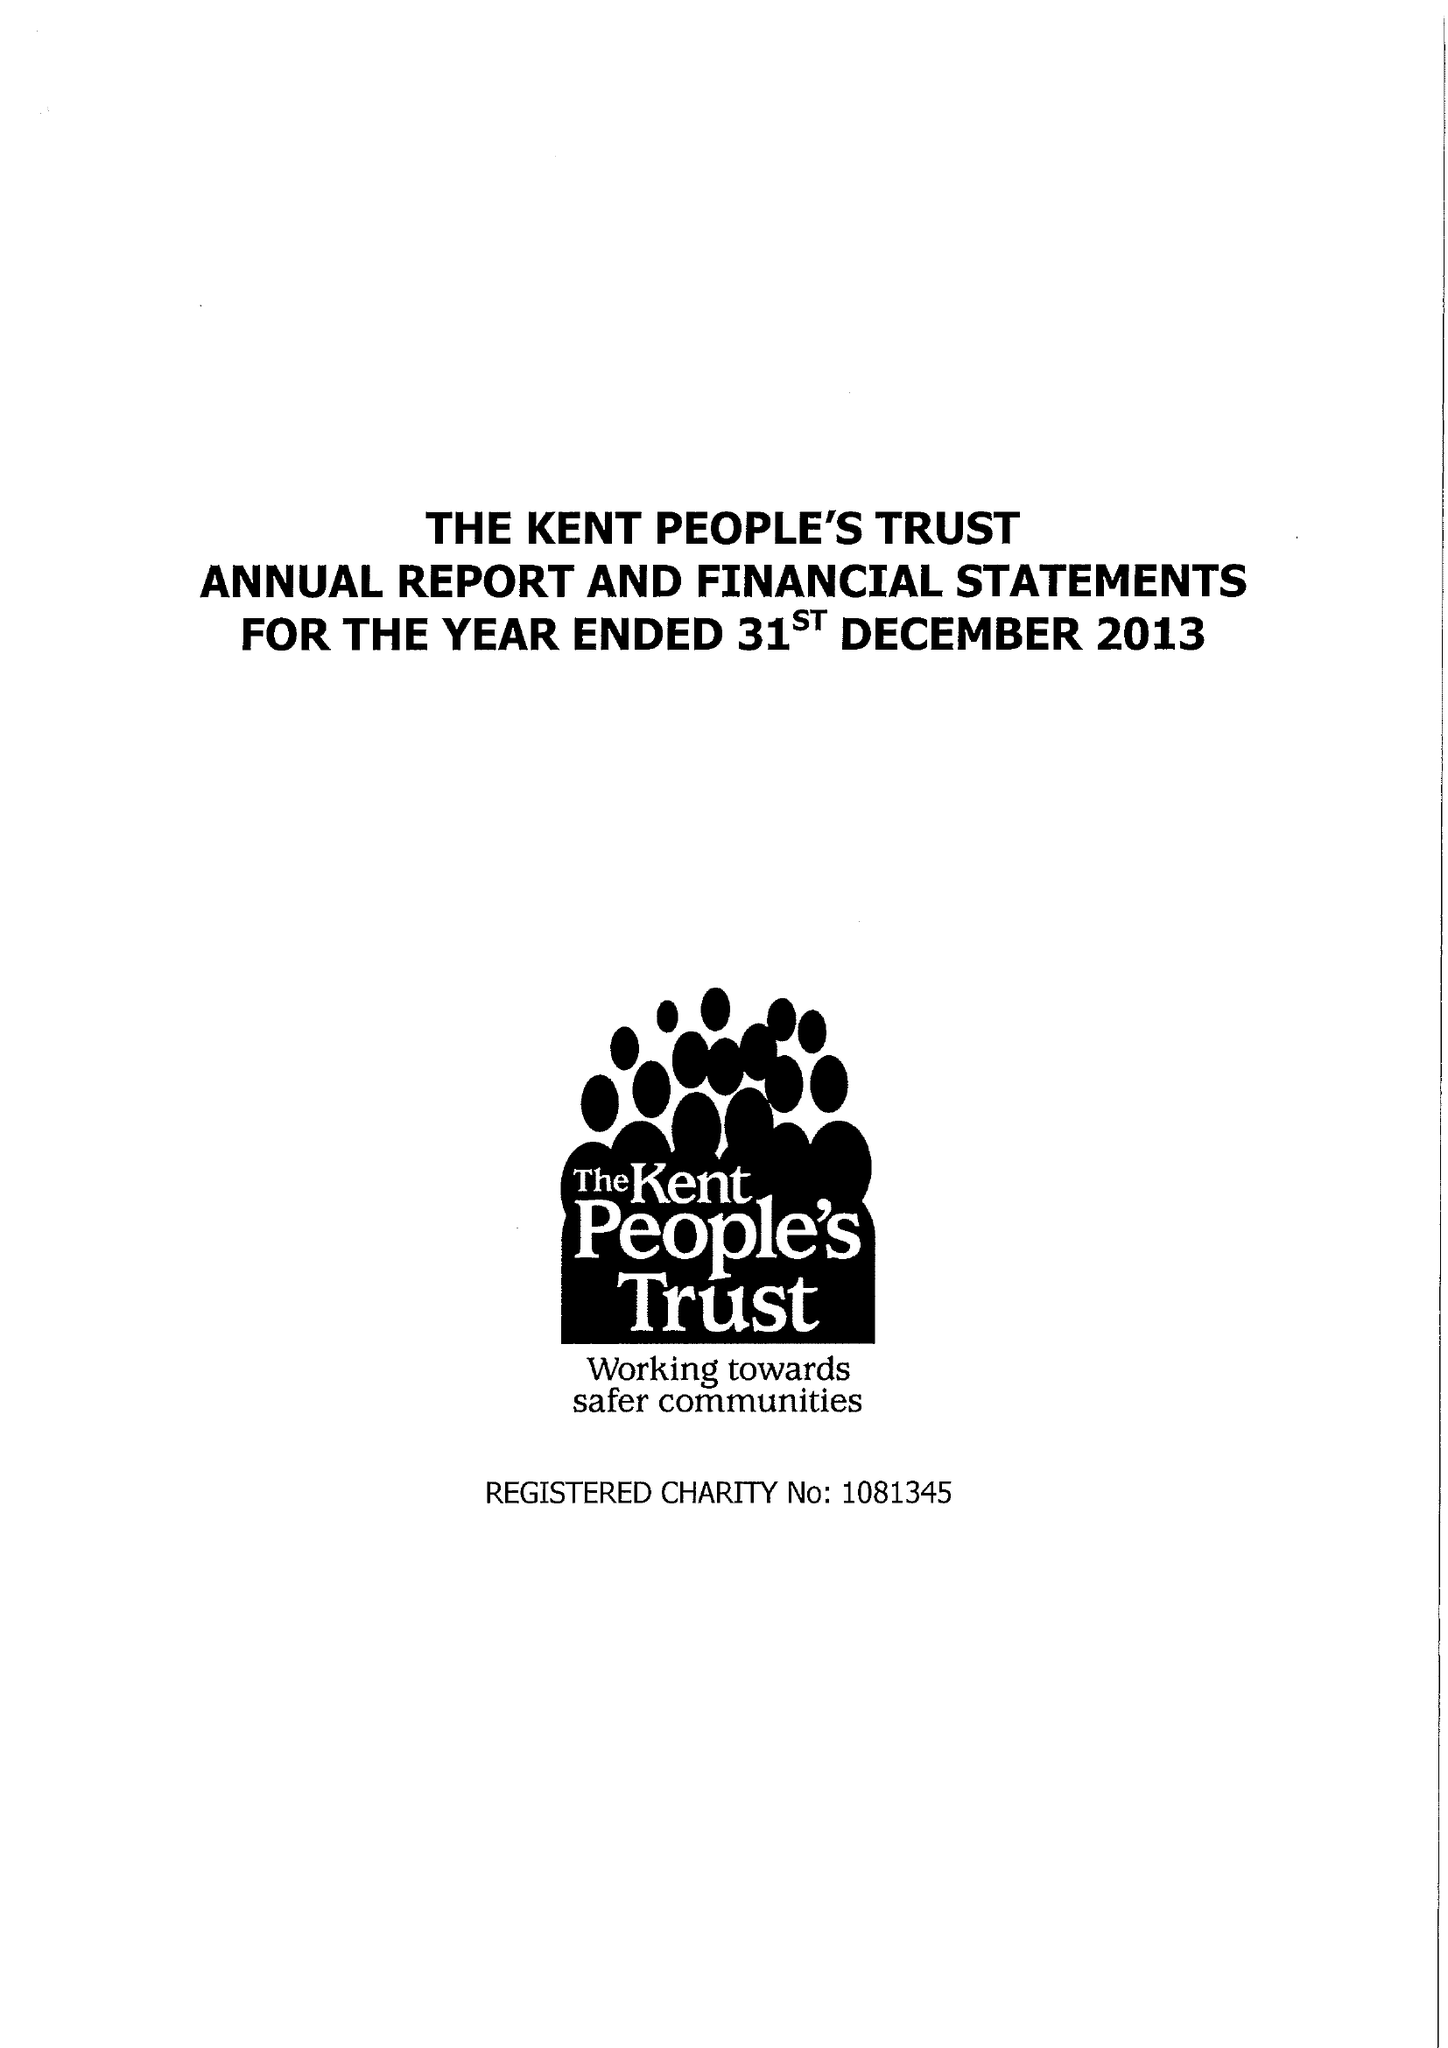What is the value for the charity_number?
Answer the question using a single word or phrase. 1081345 